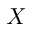Convert formula to latex. <formula><loc_0><loc_0><loc_500><loc_500>X</formula> 